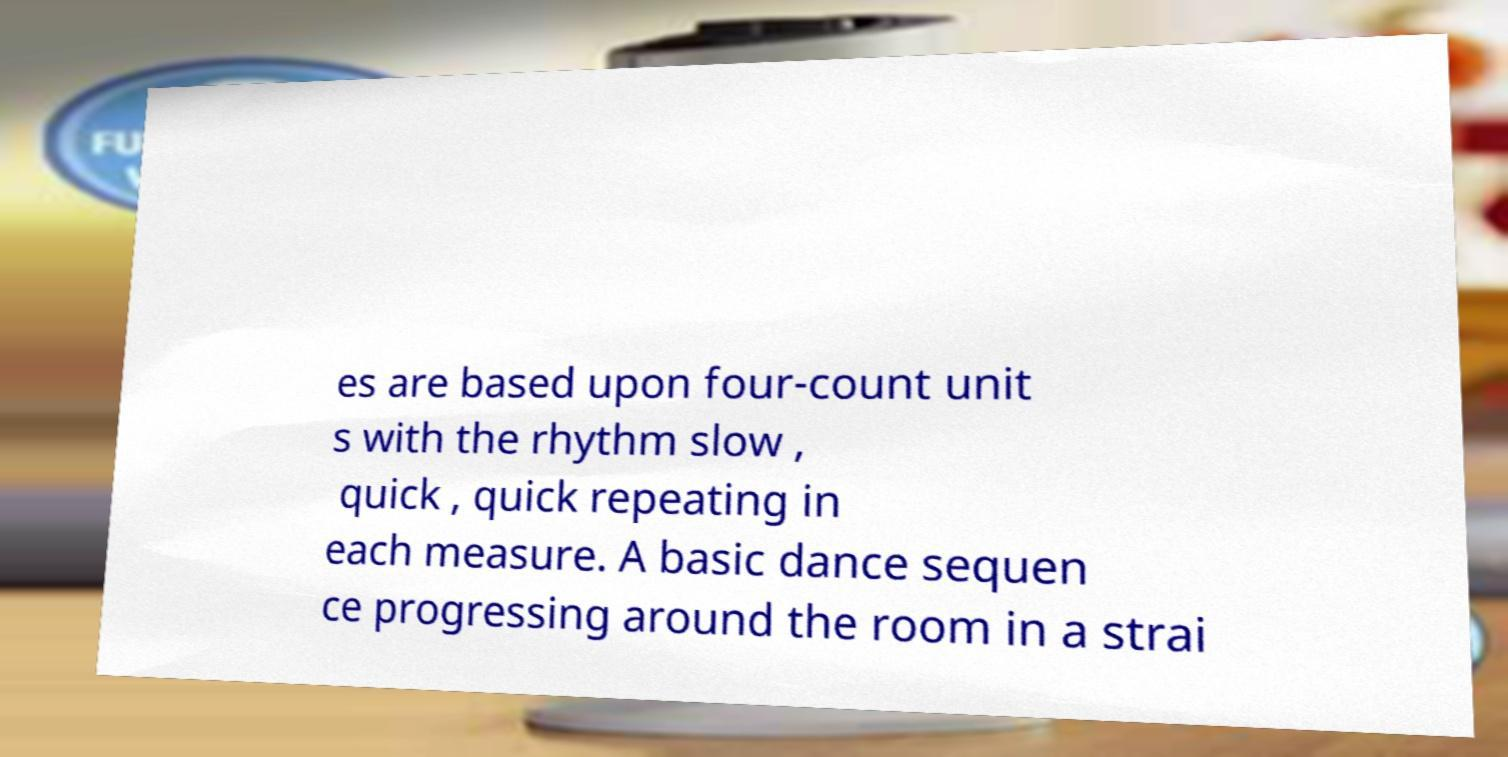Please identify and transcribe the text found in this image. es are based upon four-count unit s with the rhythm slow , quick , quick repeating in each measure. A basic dance sequen ce progressing around the room in a strai 